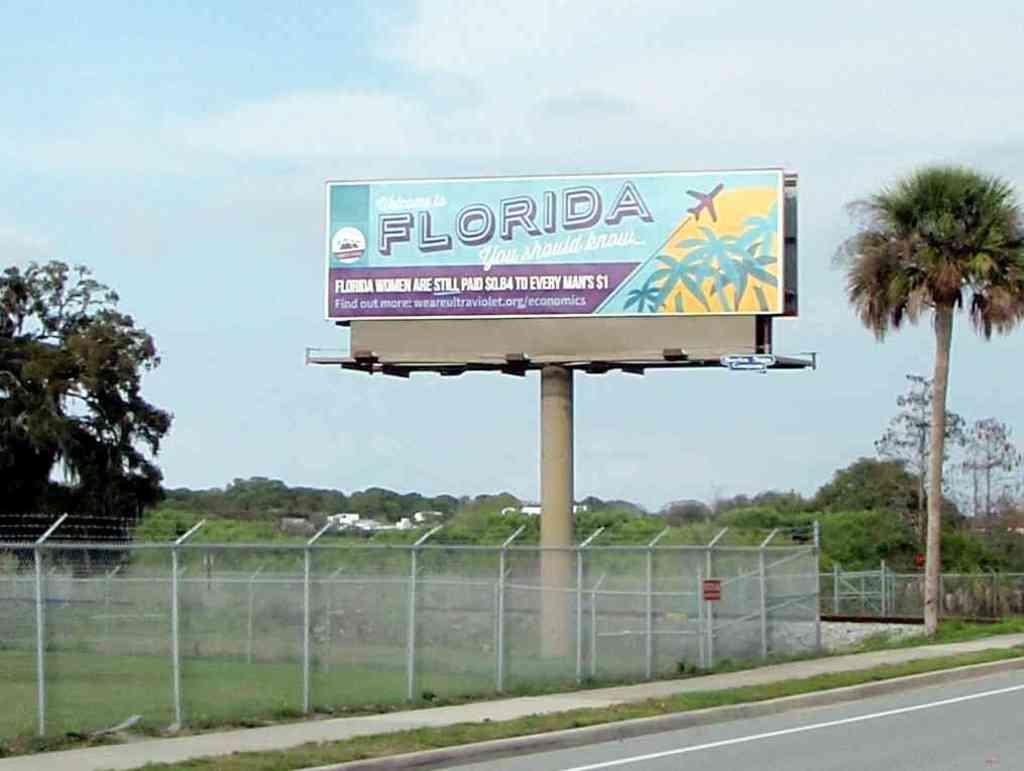<image>
Describe the image concisely. A billboard in Florida pointing out that women are paid less than men for the same job in that state. 